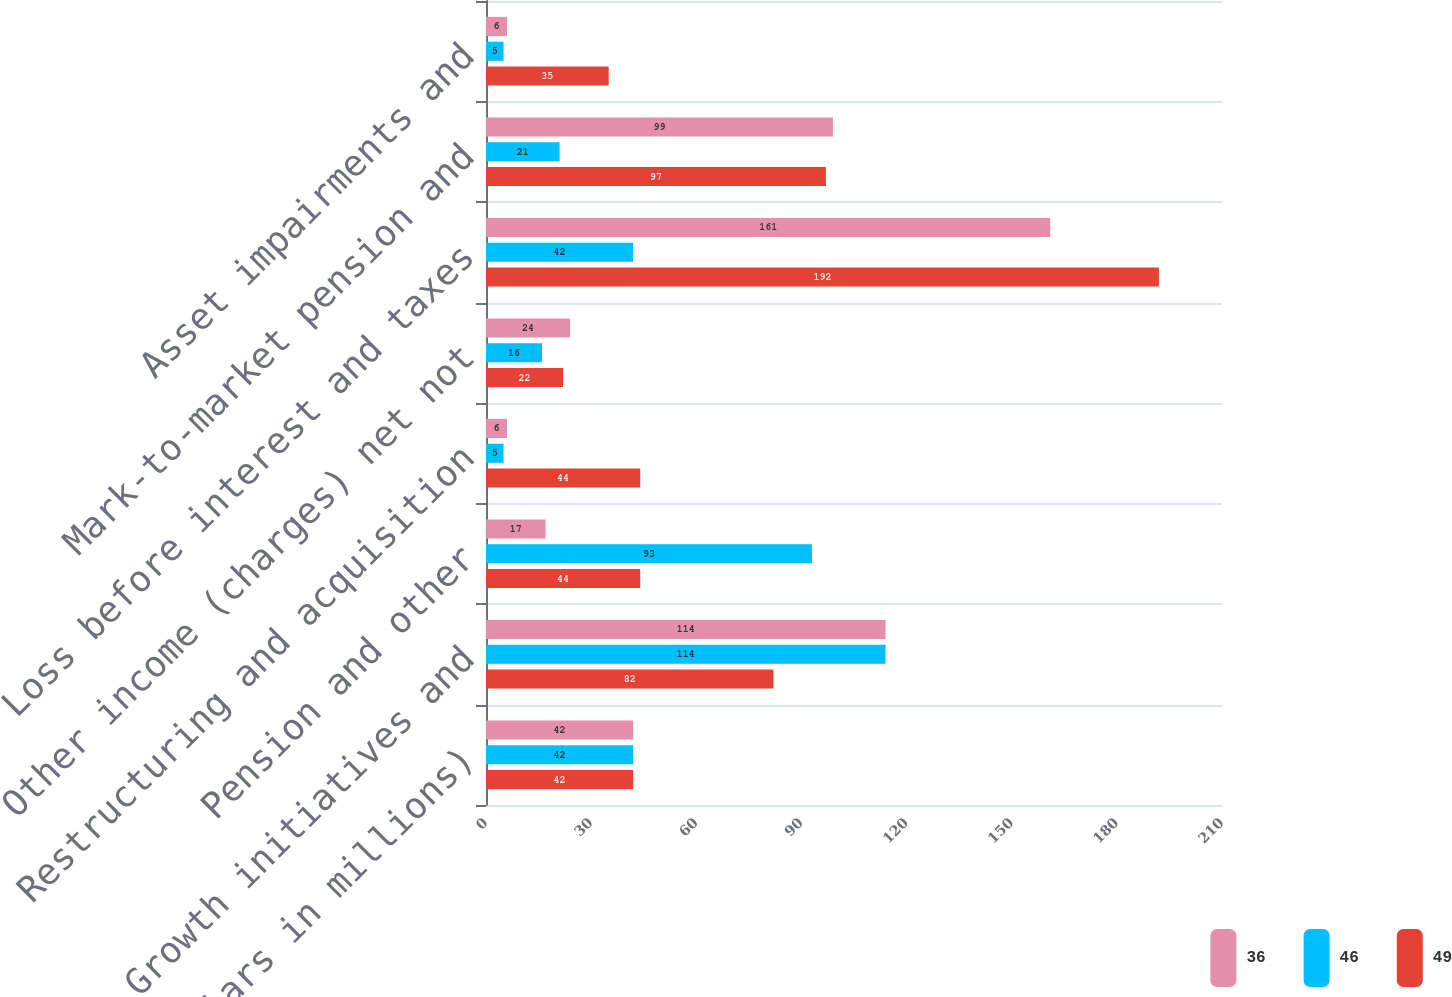<chart> <loc_0><loc_0><loc_500><loc_500><stacked_bar_chart><ecel><fcel>(Dollars in millions)<fcel>Growth initiatives and<fcel>Pension and other<fcel>Restructuring and acquisition<fcel>Other income (charges) net not<fcel>Loss before interest and taxes<fcel>Mark-to-market pension and<fcel>Asset impairments and<nl><fcel>36<fcel>42<fcel>114<fcel>17<fcel>6<fcel>24<fcel>161<fcel>99<fcel>6<nl><fcel>46<fcel>42<fcel>114<fcel>93<fcel>5<fcel>16<fcel>42<fcel>21<fcel>5<nl><fcel>49<fcel>42<fcel>82<fcel>44<fcel>44<fcel>22<fcel>192<fcel>97<fcel>35<nl></chart> 